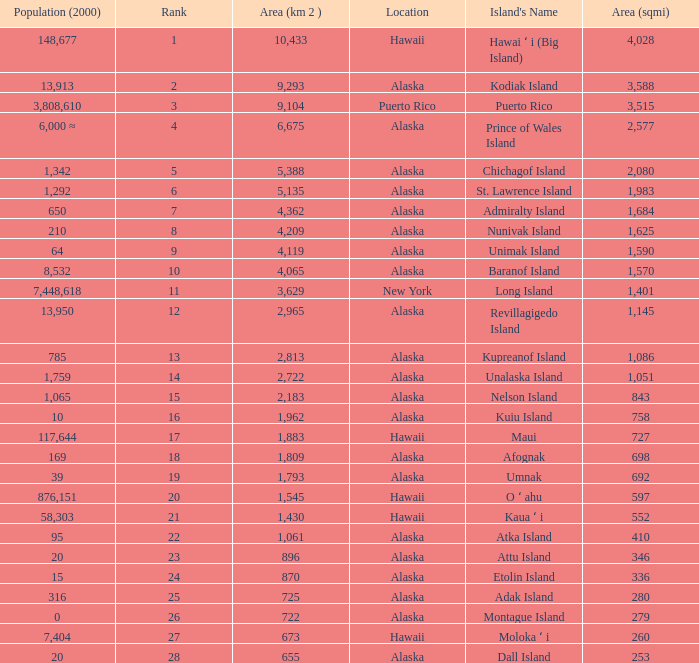What is the highest rank for Nelson Island with area more than 2,183? None. Can you give me this table as a dict? {'header': ['Population (2000)', 'Rank', 'Area (km 2 )', 'Location', "Island's Name", 'Area (sqmi)'], 'rows': [['148,677', '1', '10,433', 'Hawaii', 'Hawai ʻ i (Big Island)', '4,028'], ['13,913', '2', '9,293', 'Alaska', 'Kodiak Island', '3,588'], ['3,808,610', '3', '9,104', 'Puerto Rico', 'Puerto Rico', '3,515'], ['6,000 ≈', '4', '6,675', 'Alaska', 'Prince of Wales Island', '2,577'], ['1,342', '5', '5,388', 'Alaska', 'Chichagof Island', '2,080'], ['1,292', '6', '5,135', 'Alaska', 'St. Lawrence Island', '1,983'], ['650', '7', '4,362', 'Alaska', 'Admiralty Island', '1,684'], ['210', '8', '4,209', 'Alaska', 'Nunivak Island', '1,625'], ['64', '9', '4,119', 'Alaska', 'Unimak Island', '1,590'], ['8,532', '10', '4,065', 'Alaska', 'Baranof Island', '1,570'], ['7,448,618', '11', '3,629', 'New York', 'Long Island', '1,401'], ['13,950', '12', '2,965', 'Alaska', 'Revillagigedo Island', '1,145'], ['785', '13', '2,813', 'Alaska', 'Kupreanof Island', '1,086'], ['1,759', '14', '2,722', 'Alaska', 'Unalaska Island', '1,051'], ['1,065', '15', '2,183', 'Alaska', 'Nelson Island', '843'], ['10', '16', '1,962', 'Alaska', 'Kuiu Island', '758'], ['117,644', '17', '1,883', 'Hawaii', 'Maui', '727'], ['169', '18', '1,809', 'Alaska', 'Afognak', '698'], ['39', '19', '1,793', 'Alaska', 'Umnak', '692'], ['876,151', '20', '1,545', 'Hawaii', 'O ʻ ahu', '597'], ['58,303', '21', '1,430', 'Hawaii', 'Kaua ʻ i', '552'], ['95', '22', '1,061', 'Alaska', 'Atka Island', '410'], ['20', '23', '896', 'Alaska', 'Attu Island', '346'], ['15', '24', '870', 'Alaska', 'Etolin Island', '336'], ['316', '25', '725', 'Alaska', 'Adak Island', '280'], ['0', '26', '722', 'Alaska', 'Montague Island', '279'], ['7,404', '27', '673', 'Hawaii', 'Moloka ʻ i', '260'], ['20', '28', '655', 'Alaska', 'Dall Island', '253']]} 